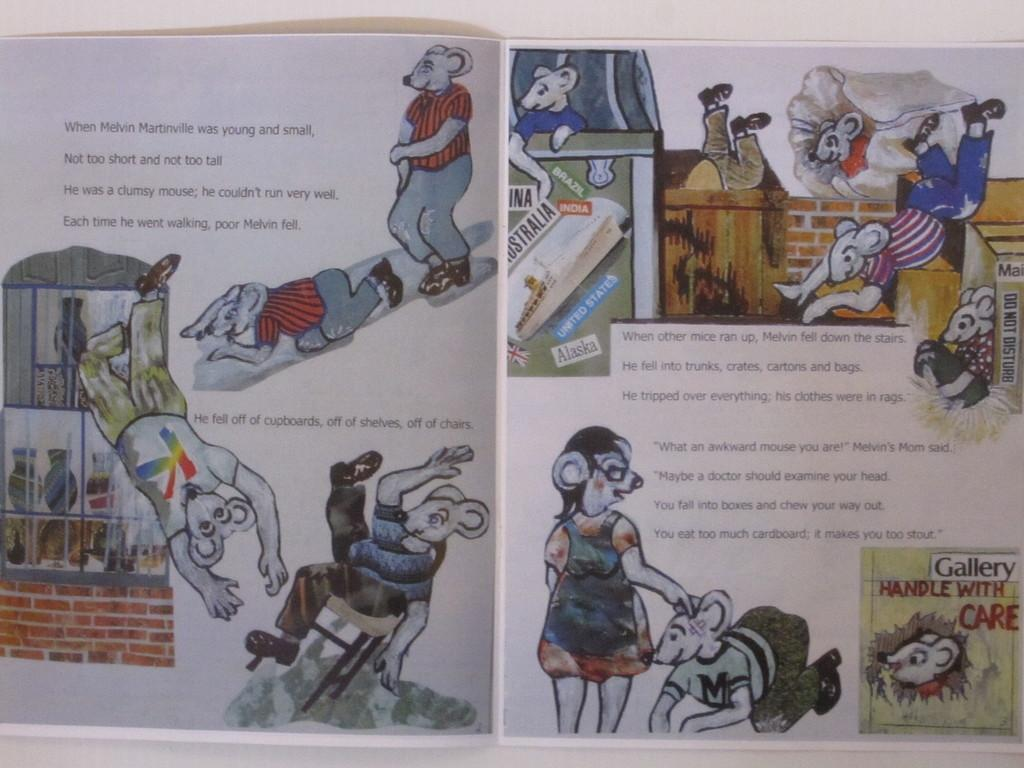<image>
Render a clear and concise summary of the photo. a story that is about mice in many colors 